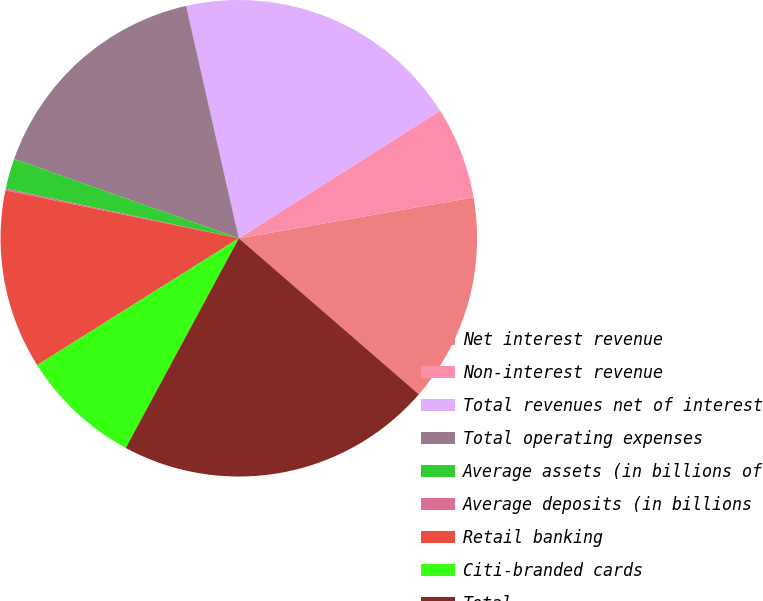Convert chart to OTSL. <chart><loc_0><loc_0><loc_500><loc_500><pie_chart><fcel>Net interest revenue<fcel>Non-interest revenue<fcel>Total revenues net of interest<fcel>Total operating expenses<fcel>Average assets (in billions of<fcel>Average deposits (in billions<fcel>Retail banking<fcel>Citi-branded cards<fcel>Total<nl><fcel>14.11%<fcel>6.25%<fcel>19.56%<fcel>16.05%<fcel>2.06%<fcel>0.12%<fcel>12.16%<fcel>8.19%<fcel>21.5%<nl></chart> 